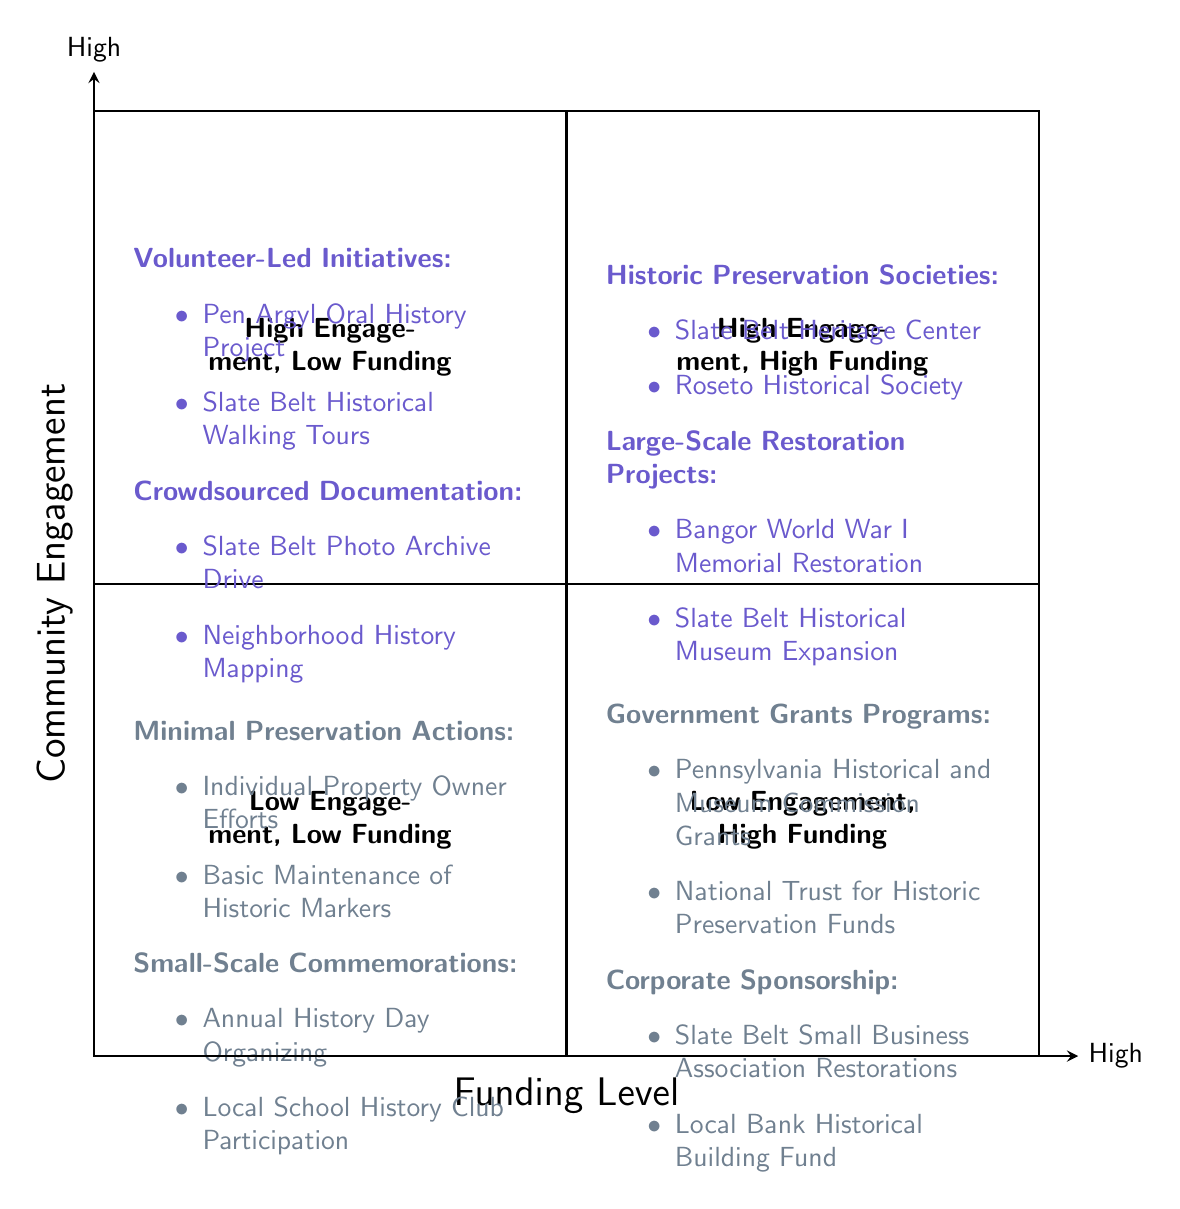What organizations are listed under high community engagement and high funding? The quadrant for high community engagement and high funding shows two categories: Historic Preservation Societies and Large-Scale Restoration Projects. The organizations specifically listed under this quadrant are the Slate Belt Heritage Center and Roseto Historical Society under Historic Preservation Societies, and Bangor World War I Memorial Restoration and Slate Belt Historical Museum Expansion under Large-Scale Restoration Projects.
Answer: Slate Belt Heritage Center, Roseto Historical Society, Bangor World War I Memorial Restoration, Slate Belt Historical Museum Expansion What types of initiatives are mentioned for low community engagement and low funding? In the quadrant for low community engagement and low funding, the initiatives included are Minimal Preservation Actions and Small-Scale Commemorations. The specific examples for Minimal Preservation Actions are Individual Property Owner Efforts and Basic Maintenance of Historic Markers, while Small-Scale Commemorations include Annual History Day Organizing and Local School History Club Participation.
Answer: Individual Property Owner Efforts, Basic Maintenance of Historic Markers, Annual History Day Organizing, Local School History Club Participation How many types of initiatives are listed in the high engagement, low funding quadrant? In this quadrant, there are two main types of initiatives outlined: Volunteer-Led Initiatives and Crowdsourced Documentation. Each type includes specific examples, but the question asks only for the types of initiatives, which amounts to two.
Answer: 2 Which quadrant contains Government Grants Programs? Government Grants Programs are located in the low engagement, high funding quadrant. This quadrant also includes Corporate Sponsorship as another category. By looking at the bottom right section of the diagram, it becomes clear where these programs are situated.
Answer: Low Engagement, High Funding What is the relationship between community engagement and funding levels in the high engagement sections? In the high engagement sections of the diagram, specifically the high community engagement and high funding quadrant, activities are more structured and supported by organized entities such as historic preservation societies, leading to large-scale restoration projects. This contrasts with high engagement, low funding, which relies on volunteer efforts and documented community contributions.
Answer: Organized support vs. volunteer efforts Which initiatives represent low community engagement but high funding? The initiatives that represent low community engagement but high funding include Government Grants Programs and Corporate Sponsorship. These reflect the financial backing present without active community involvement in the initiatives themselves.
Answer: Government Grants Programs, Corporate Sponsorship What is the main characteristic of the high engagement, low funding quadrant? The main characteristic of the high engagement, low funding quadrant is community-driven efforts that rely heavily on volunteer work and participation, emphasizing grassroots actions without substantial financial resources. This quadrant highlights how community involvement can thrive even when funding is limited.
Answer: Community-driven volunteer efforts Name one event type found in the low engagement, low funding quadrant. The low engagement, low funding quadrant lists several types of smaller initiatives, one of which is the Annual History Day Organizing. This event type represents efforts to commemorate local history with minimal financial input and care from community members.
Answer: Annual History Day Organizing 